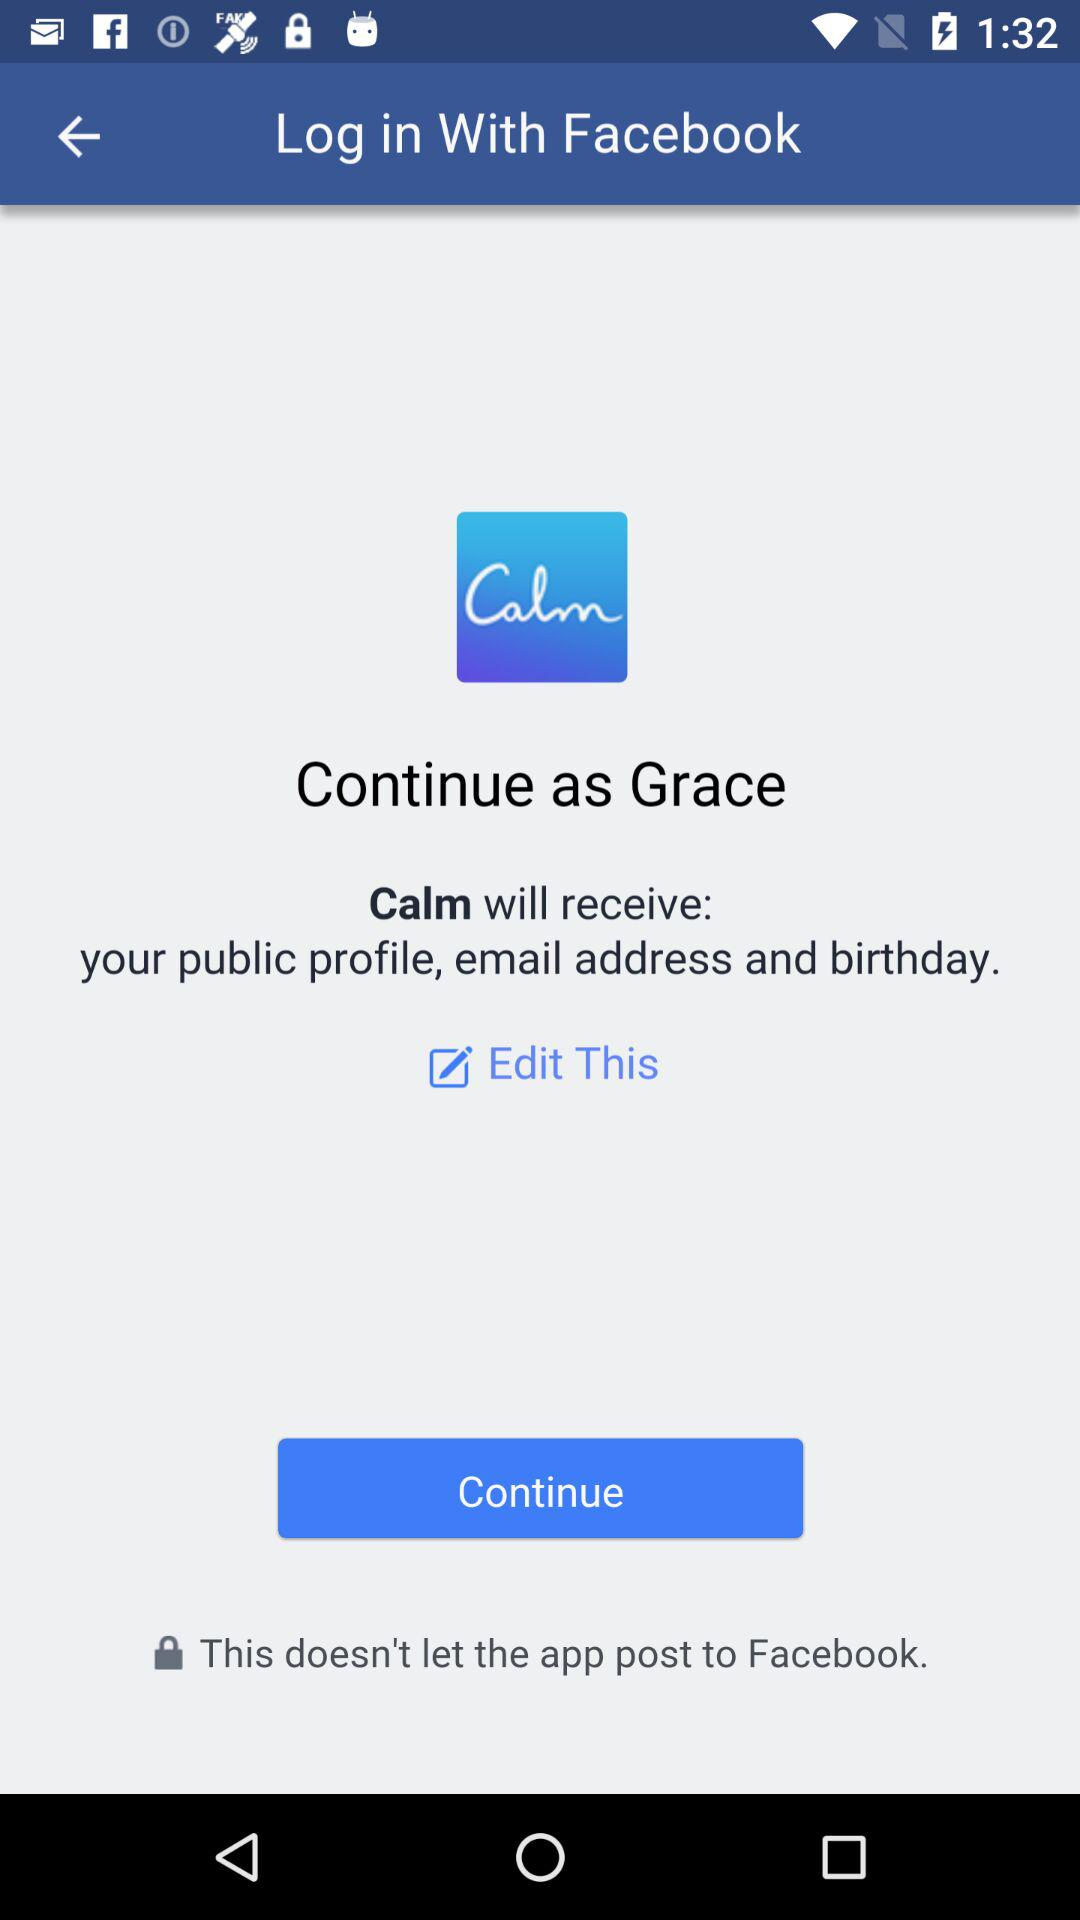What is the login name? The login name is Grace. 